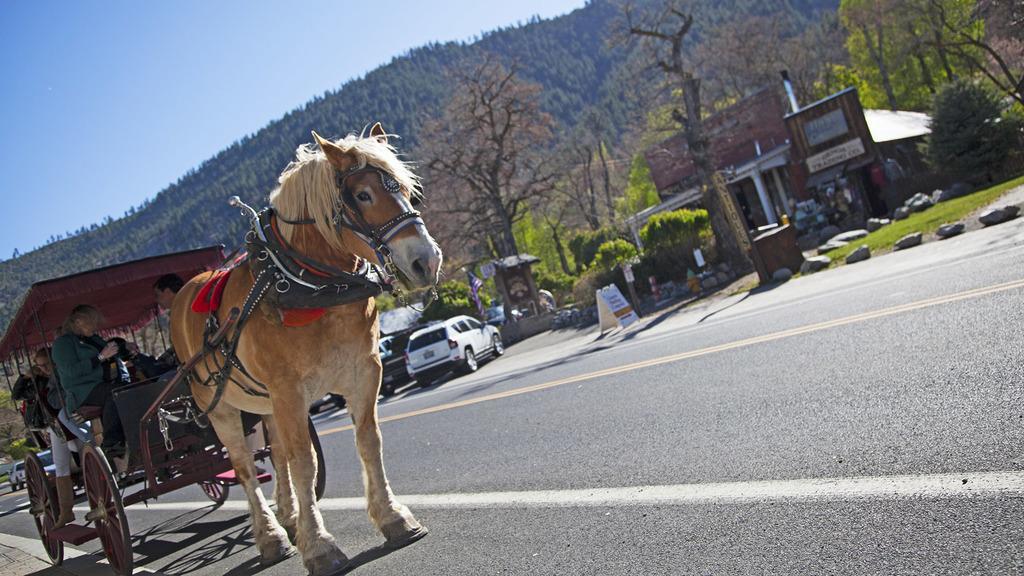In one or two sentences, can you explain what this image depicts? There is a horse cart. Inside the car there are many people. There is a road. There are vehicles on the road. In the back there are trees, building, rocks and sky. 